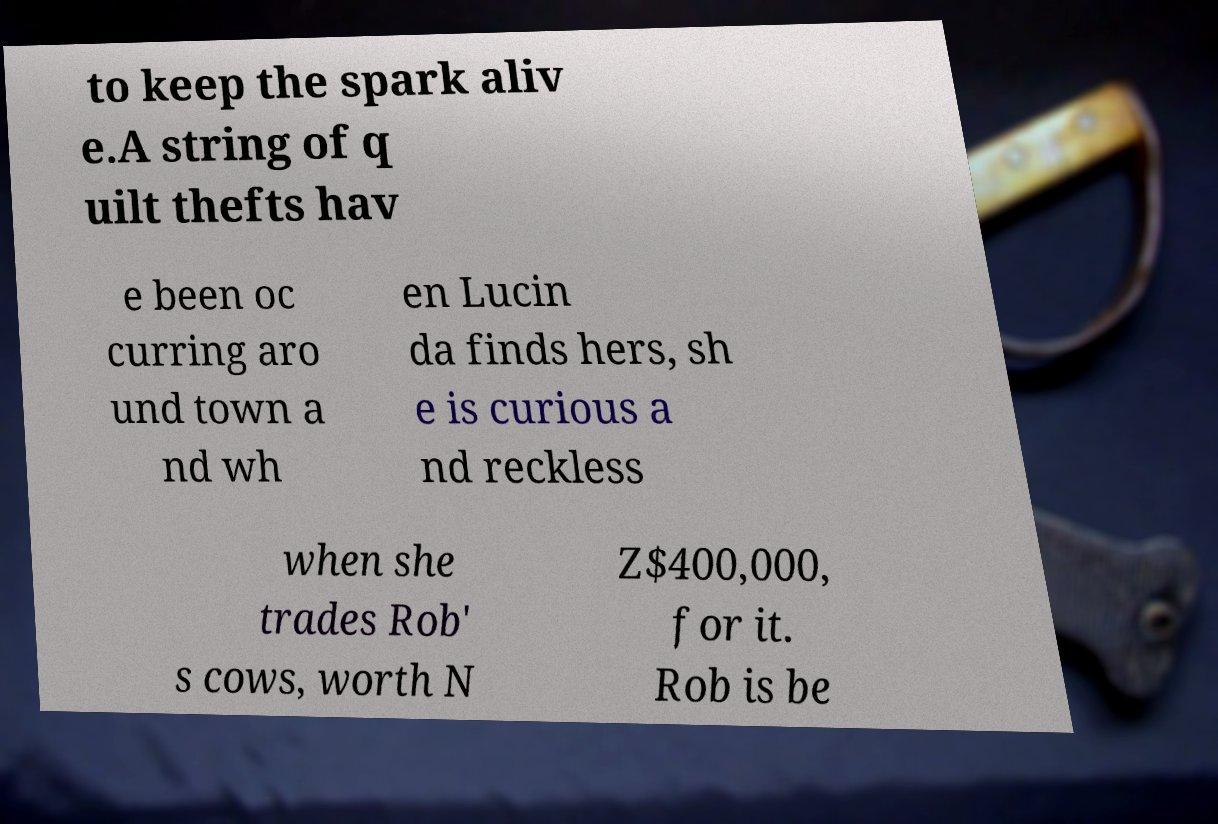Can you read and provide the text displayed in the image?This photo seems to have some interesting text. Can you extract and type it out for me? to keep the spark aliv e.A string of q uilt thefts hav e been oc curring aro und town a nd wh en Lucin da finds hers, sh e is curious a nd reckless when she trades Rob' s cows, worth N Z$400,000, for it. Rob is be 